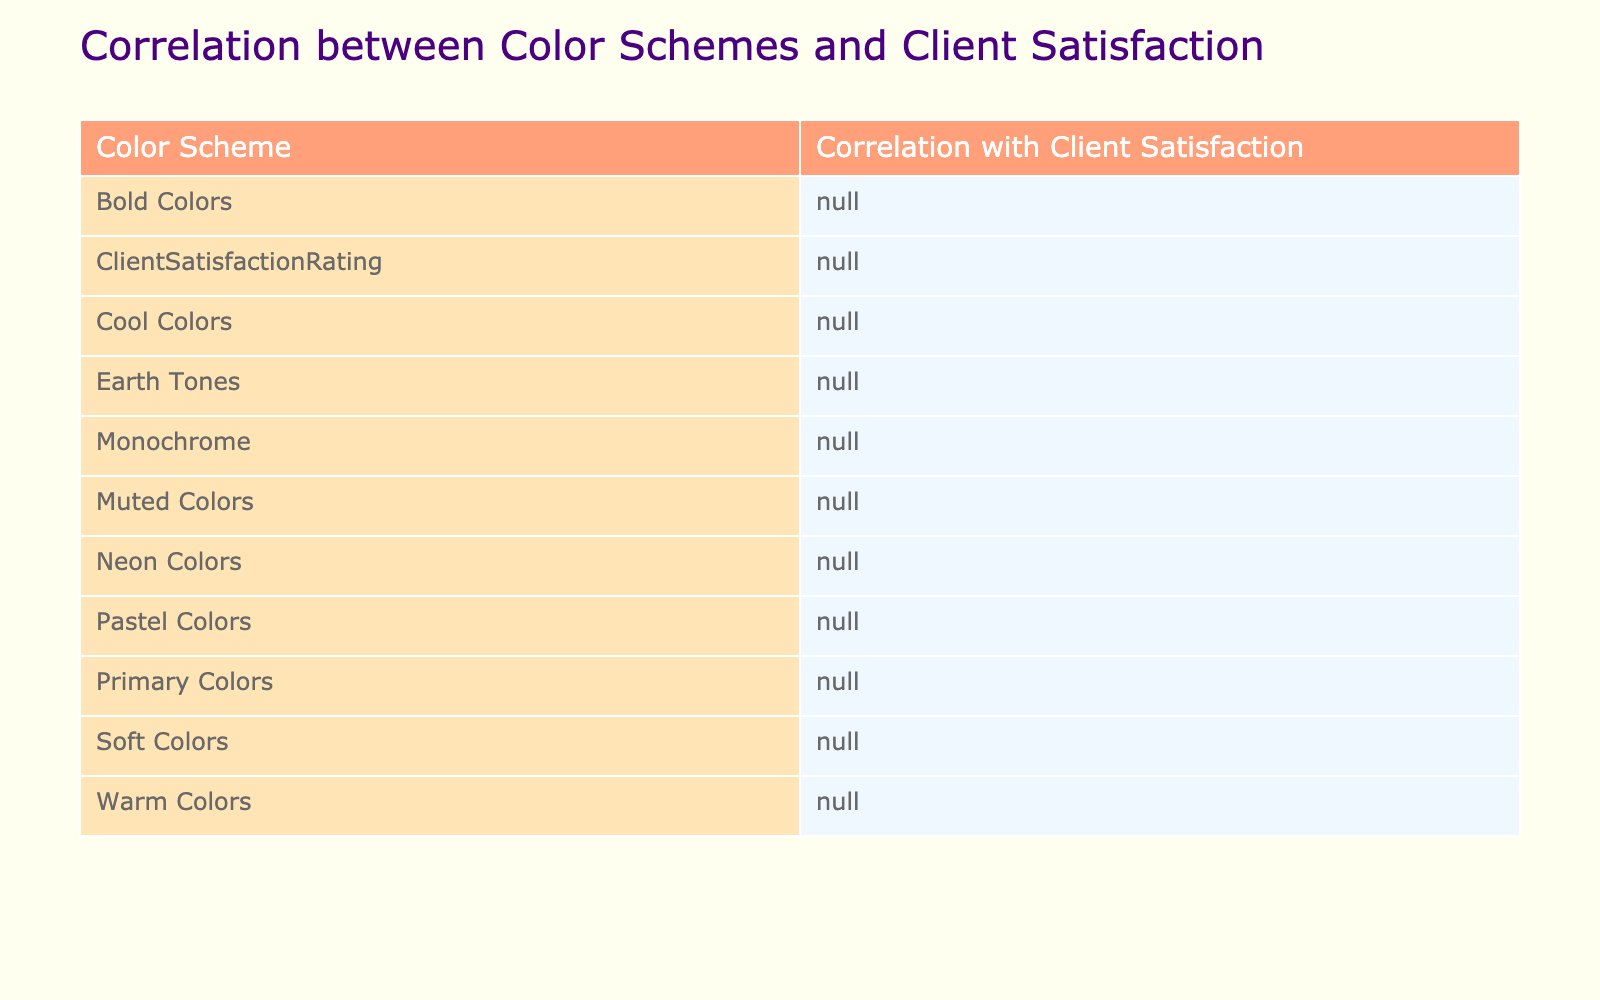What is the highest client satisfaction rating observed in the table? By examining the "Client Satisfaction Rating" column, the highest rating is 95, which corresponds to "Soft Colors."
Answer: 95 What color scheme has the lowest correlation with client satisfaction? The table shows that "Muted Colors" has a correlation value of 75, which is the lowest among all color schemes listed.
Answer: 75 Is "Cool Colors" associated with a higher client satisfaction rating than "Bold Colors"? Comparing the ratings, "Cool Colors" has a rating of 90, while "Bold Colors" has a rating of 83. Since 90 is greater than 83, "Cool Colors" is associated with higher satisfaction.
Answer: Yes What is the average client satisfaction rating of all color schemes? To calculate the average, we sum all the satisfaction ratings: 85 + 90 + 78 + 92 + 80 + 88 + 83 + 95 + 91 + 75 = 882, and then divide by the number of projects (10). Thus, the average is 882 / 10 = 88.2.
Answer: 88.2 Are there any color schemes that correspond to a client satisfaction rating of 90 or higher? From the table, the color schemes that have ratings of 90 or above are "Cool Colors" (90), "Pastel Colors" (92), "Soft Colors" (95), and "Primary Colors" (91). Therefore, there are multiple color schemes that meet this criterion.
Answer: Yes How many color schemes have a client satisfaction rating below 80? Looking at the ratings, only "Monochrome" (78) and "Muted Colors" (75) fall below 80. Thus, there are two color schemes with ratings under 80.
Answer: 2 What difference in client satisfaction rating exists between "Warm Colors" and "Earth Tones"? "Warm Colors" has a rating of 85 while "Earth Tones" has a rating of 88. Thus, the difference is calculated as 88 - 85, resulting in a difference of 3.
Answer: 3 Which project type corresponds to the "Muted Colors" scheme? By examining the table, "Muted Colors" corresponds to "Minimalist Magazine," which directly links the project type to the color scheme.
Answer: Minimalist Magazine Which color scheme exhibits a correlation with client satisfaction that is greater than 85? From the table, "Cool Colors" (90), "Earth Tones" (88), "Pastel Colors" (92), "Soft Colors" (95), and "Primary Colors" (91) all have correlations that exceed 85.
Answer: Cool Colors, Earth Tones, Pastel Colors, Soft Colors, Primary Colors 